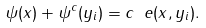Convert formula to latex. <formula><loc_0><loc_0><loc_500><loc_500>\psi ( x ) + \psi ^ { c } ( y _ { i } ) = c _ { \ } e ( x , y _ { i } ) .</formula> 